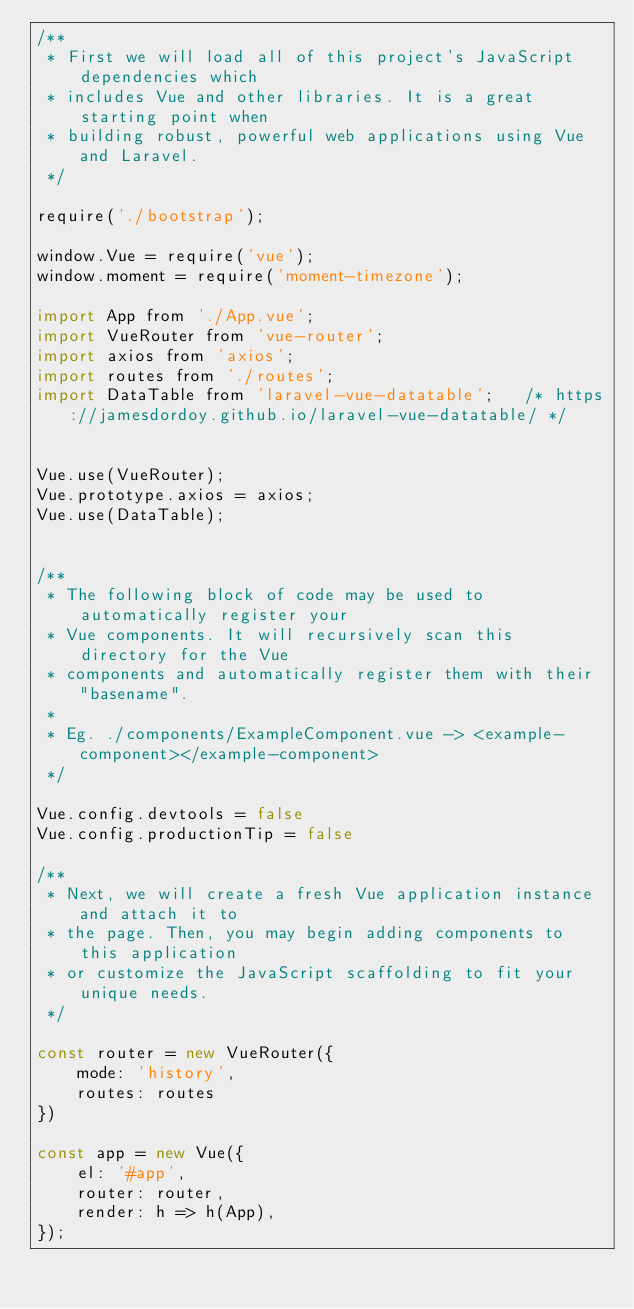<code> <loc_0><loc_0><loc_500><loc_500><_JavaScript_>/**
 * First we will load all of this project's JavaScript dependencies which
 * includes Vue and other libraries. It is a great starting point when
 * building robust, powerful web applications using Vue and Laravel.
 */

require('./bootstrap');

window.Vue = require('vue');
window.moment = require('moment-timezone');

import App from './App.vue';
import VueRouter from 'vue-router';
import axios from 'axios';
import routes from './routes';
import DataTable from 'laravel-vue-datatable';   /* https://jamesdordoy.github.io/laravel-vue-datatable/ */


Vue.use(VueRouter);
Vue.prototype.axios = axios;
Vue.use(DataTable);


/**
 * The following block of code may be used to automatically register your
 * Vue components. It will recursively scan this directory for the Vue
 * components and automatically register them with their "basename".
 *
 * Eg. ./components/ExampleComponent.vue -> <example-component></example-component>
 */

Vue.config.devtools = false
Vue.config.productionTip = false

/**
 * Next, we will create a fresh Vue application instance and attach it to
 * the page. Then, you may begin adding components to this application
 * or customize the JavaScript scaffolding to fit your unique needs.
 */

const router = new VueRouter({
    mode: 'history',
    routes: routes
})

const app = new Vue({
    el: '#app',
    router: router,
    render: h => h(App),
});
</code> 